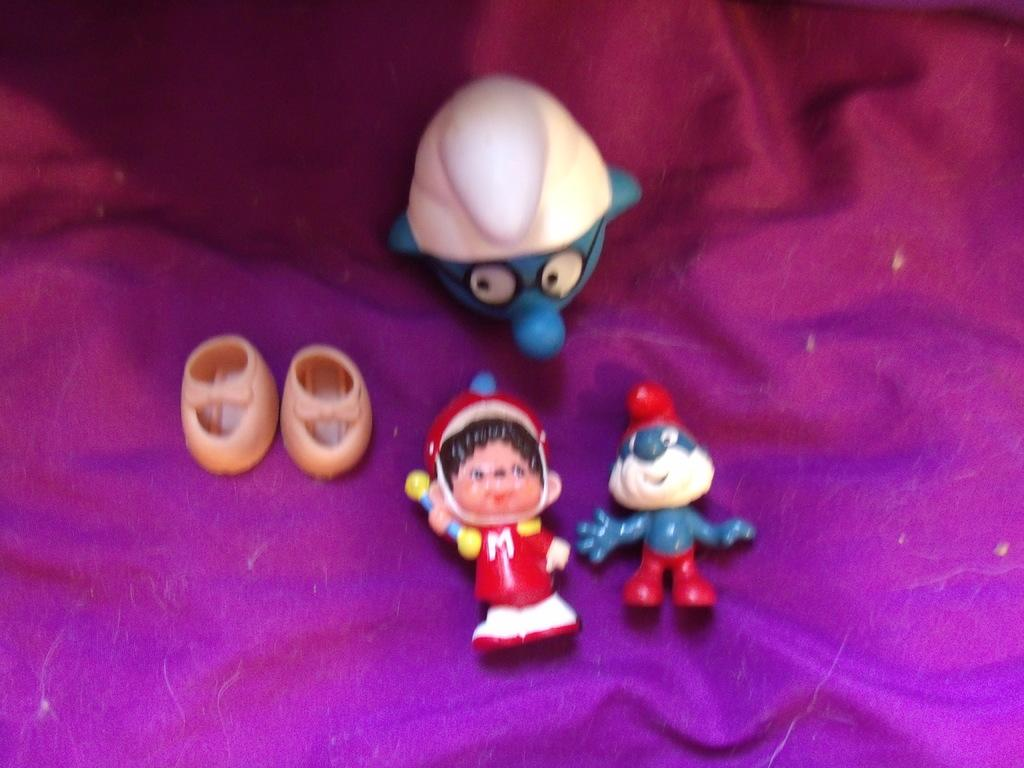What objects are present in the image? There are toys in the image. What is the toys placed on? The toys are on a pink cloth. Can you tell me how the toys are using their magical powers in the image? There is no mention of magic or magical powers in the image; the toys are simply placed on a pink cloth. 